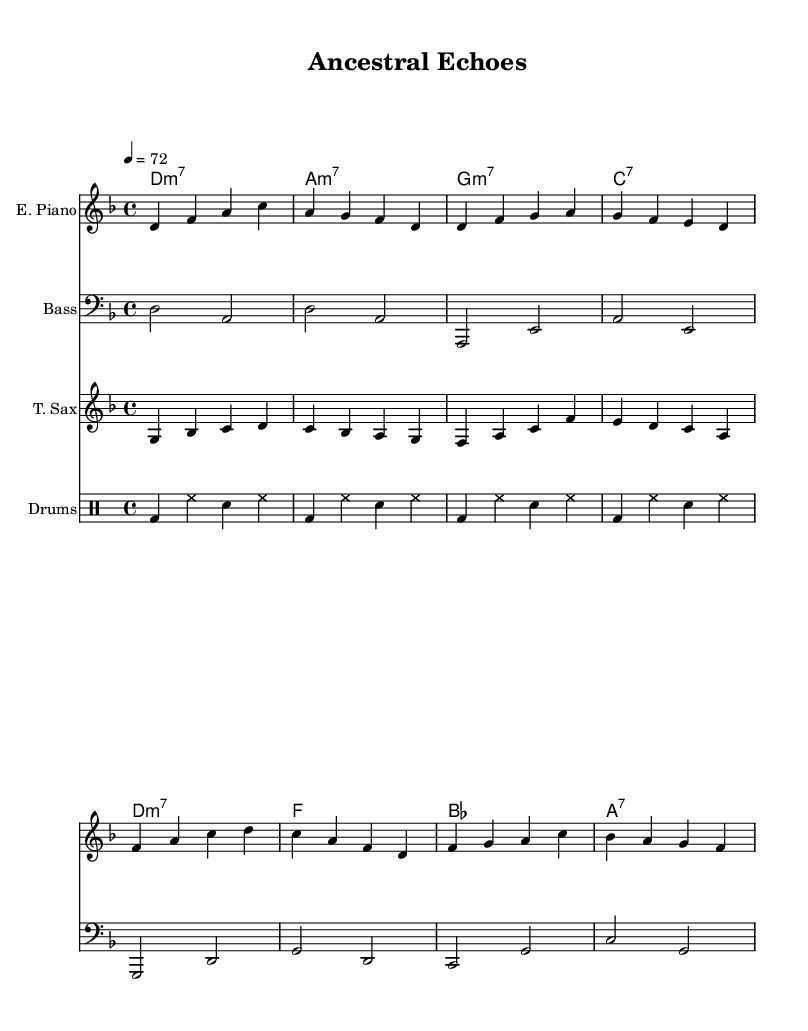What is the key signature of this music? The key signature indicates the music is in D minor, which has one flat (B flat).
Answer: D minor What is the time signature of this music? The time signature, found at the beginning, specifies that the piece is in four beats per measure (4/4).
Answer: 4/4 What is the tempo marking of this music? The tempo marking indicates the speed at which the piece should be played, which is 72 beats per minute.
Answer: 72 What instrument plays the melody in the verse? The melody is primarily played by the electric piano, as indicated by the instrumental staff labeled "E. Piano."
Answer: Electric Piano Which chord is placed at the beginning of the chorus? The first chord in the chorus is D minor 7, as specified in the chord symbols above the staff.
Answer: D minor 7 How many measures are there in the verse section? By counting the groups of four beats in the bars, we find that the verse section contains four measures.
Answer: Four measures What is the relationship between the bass line and the melody? The bass line complements the melody by providing harmonic support and rhythm while often moving in sync with the melody notes.
Answer: Complementary 